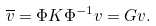Convert formula to latex. <formula><loc_0><loc_0><loc_500><loc_500>\overline { v } = \Phi K \Phi ^ { - 1 } v = G v .</formula> 